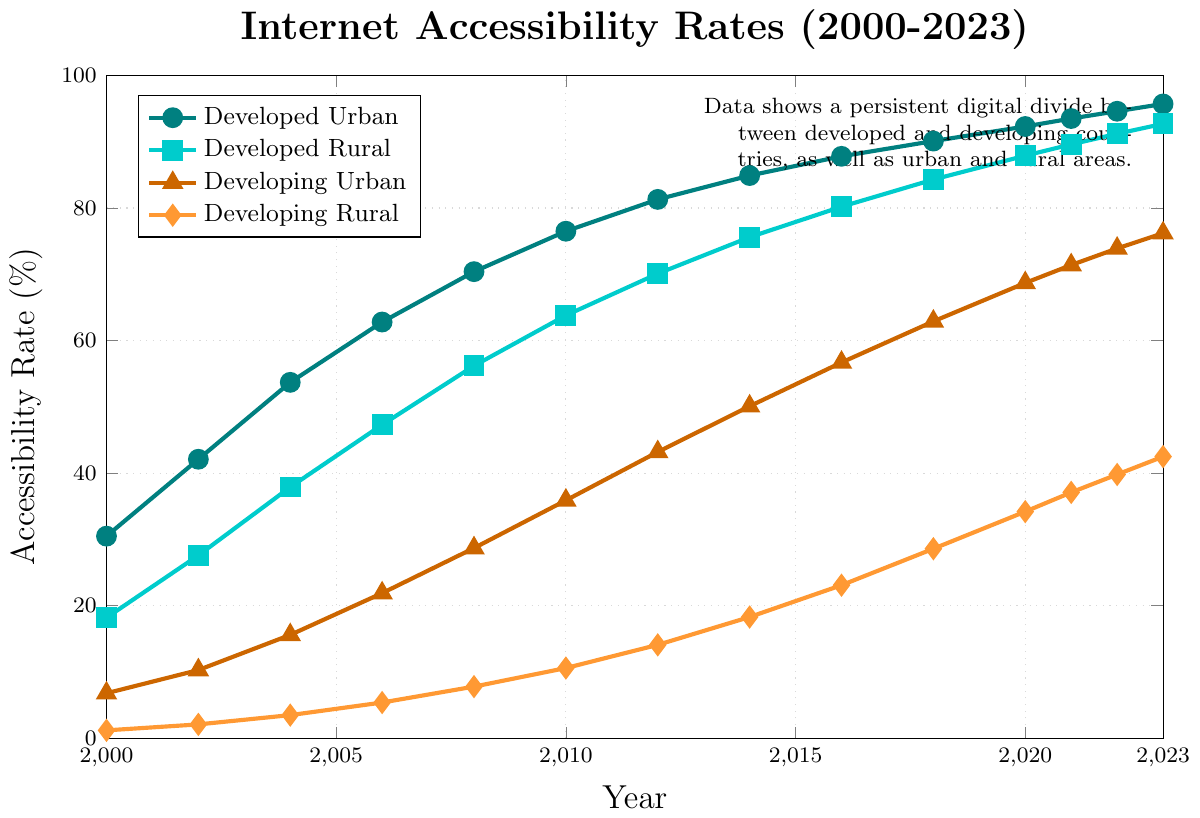What's the difference in internet accessibility rates between developed urban and developed rural areas in 2023? In 2023, the accessibility rate for developed urban areas is 95.7% and for developed rural areas is 92.7%. The difference is 95.7% - 92.7% = 3%.
Answer: 3% How has the internet accessibility rate changed for developing rural areas from 2000 to 2023? In 2000, the rate for developing rural areas was 1.2%, and in 2023, it is 42.5%. The change is 42.5% - 1.2% = 41.3%.
Answer: 41.3% Which year saw the largest increase in internet accessibility rate for developing urban areas? By examining the plot, the rate increased most rapidly from 2010 (35.9%) to 2012 (43.2%). The increase is 43.2% - 35.9% = 7.3%.
Answer: 2010 to 2012 What is the average internet accessibility rate for developed rural areas from 2000 to 2023? Summing the values for developed rural areas over the years and then dividing by the number of years: (18.2 + 27.6 + 37.9 + 47.3 + 56.2 + 63.8 + 70.1 + 75.6 + 80.2 + 84.3 + 87.9 + 89.6 + 91.2 + 92.7)/14 = 63.07%.
Answer: 63.07% Which segment lagged the most in internet accessibility rates in 2000? In 2000, the accessibility rates were: developed urban (30.5%), developed rural (18.2%), developing urban (6.8%), and developing rural (1.2%). Developing rural areas had the lowest rate at 1.2%.
Answer: Developing rural Is there any year where developing urban areas had higher internet accessibility rates than developed rural areas? By observing the rates, in every year from 2000 to 2023, developed rural areas always had higher rates compared to developing urban areas.
Answer: No What is the trend of internet accessibility rate for developed urban areas from 2000 to 2023? The trend shows a consistently increasing rate for developed urban areas, starting from 30.5% in 2000 to 95.7% in 2023.
Answer: Increasing How much did the internet accessibility rate increase for developing urban areas between 2018 and 2020? The accessibility rate for developing urban areas in 2018 was 62.9% and in 2020 was 68.7%. The increase is 68.7% - 62.9% = 5.8%.
Answer: 5.8% Between which years did developed rural areas see their highest increase in internet accessibility rate? Developed rural areas saw their highest rate increase from 2010 (63.8%) to 2012 (70.1%), with an increase of 70.1% - 63.8% = 6.3%.
Answer: 2010 to 2012 In 2023, how much higher is the internet accessibility rate in developing urban areas compared to developing rural areas? In 2023, the rate for developing urban areas is 76.2% and for developing rural areas is 42.5%. The difference is 76.2% - 42.5% = 33.7%.
Answer: 33.7% 